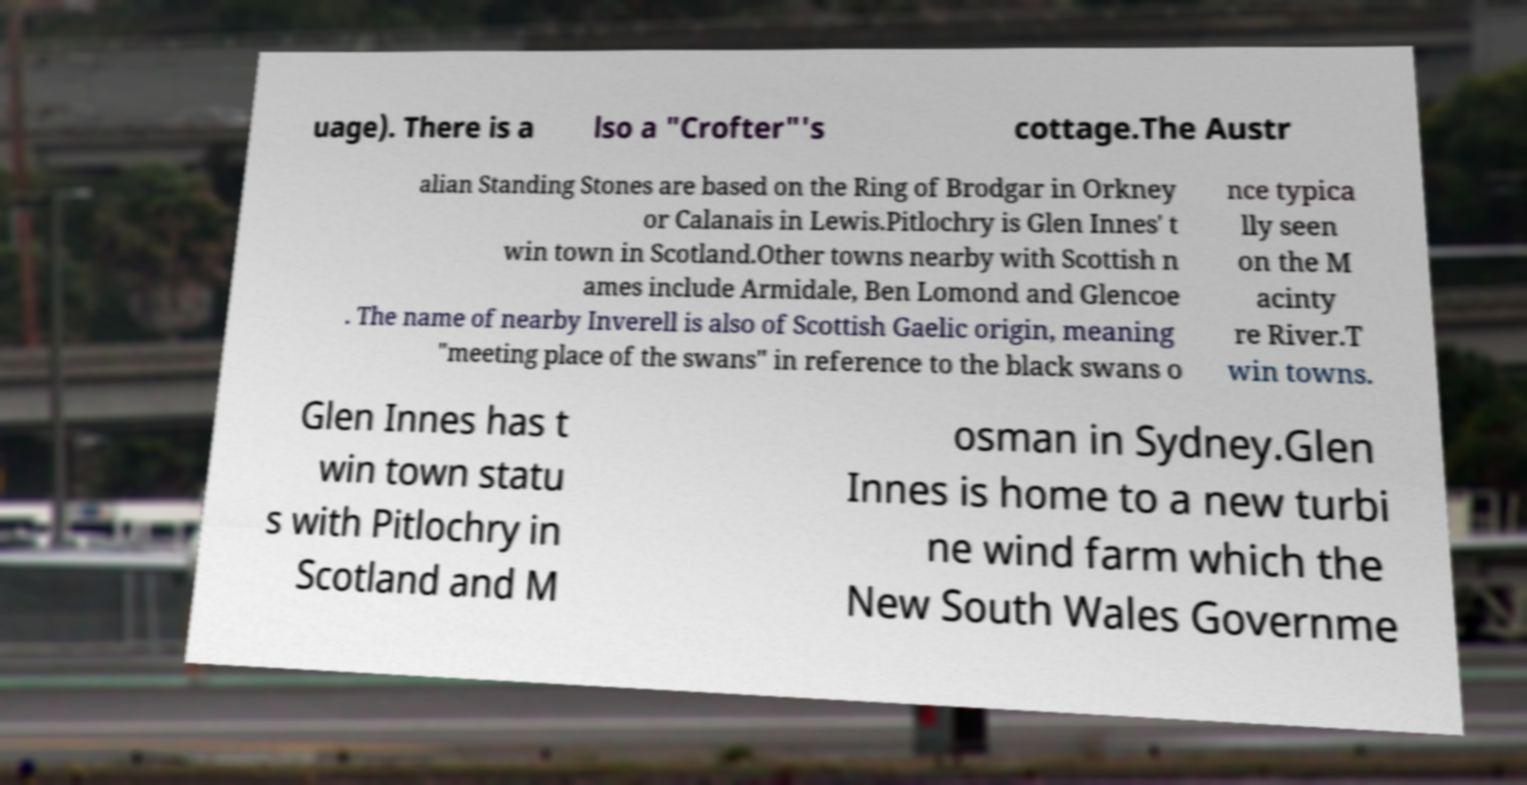I need the written content from this picture converted into text. Can you do that? uage). There is a lso a "Crofter"'s cottage.The Austr alian Standing Stones are based on the Ring of Brodgar in Orkney or Calanais in Lewis.Pitlochry is Glen Innes' t win town in Scotland.Other towns nearby with Scottish n ames include Armidale, Ben Lomond and Glencoe . The name of nearby Inverell is also of Scottish Gaelic origin, meaning "meeting place of the swans" in reference to the black swans o nce typica lly seen on the M acinty re River.T win towns. Glen Innes has t win town statu s with Pitlochry in Scotland and M osman in Sydney.Glen Innes is home to a new turbi ne wind farm which the New South Wales Governme 